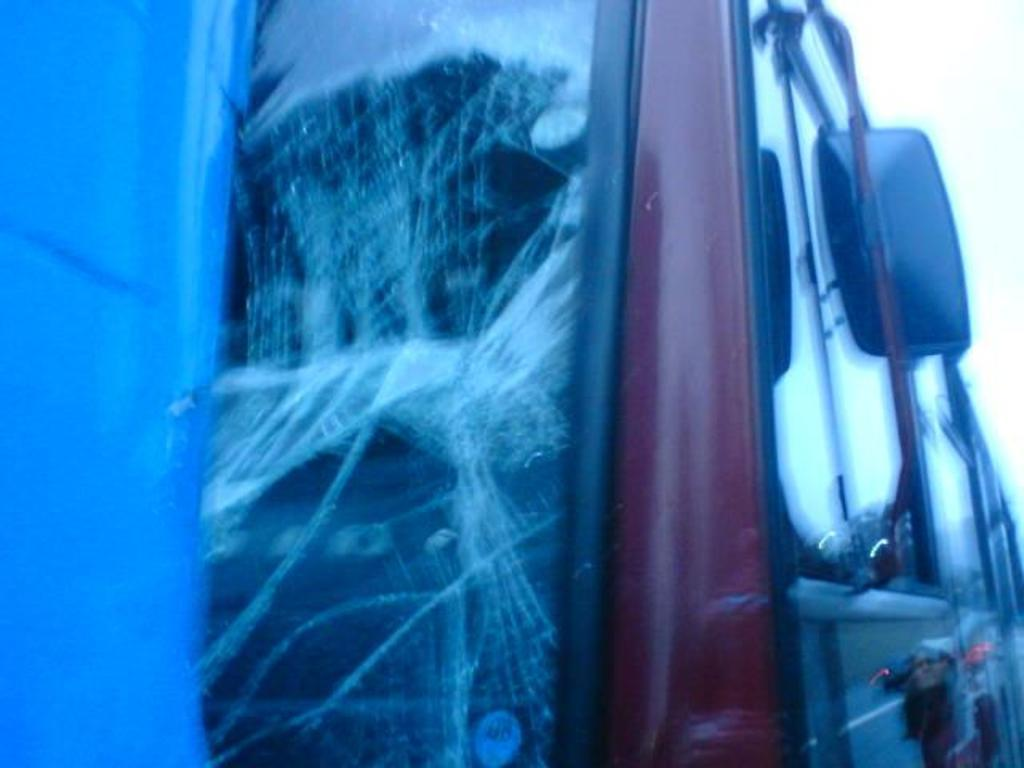What is the main subject of the image? There is a vehicle in the image. Can you describe the condition of the vehicle? The window glass of the vehicle is broken. What news is being reported on the yoke of the vehicle in the image? There is no news or yoke present in the image; it only features a vehicle with broken window glass. 